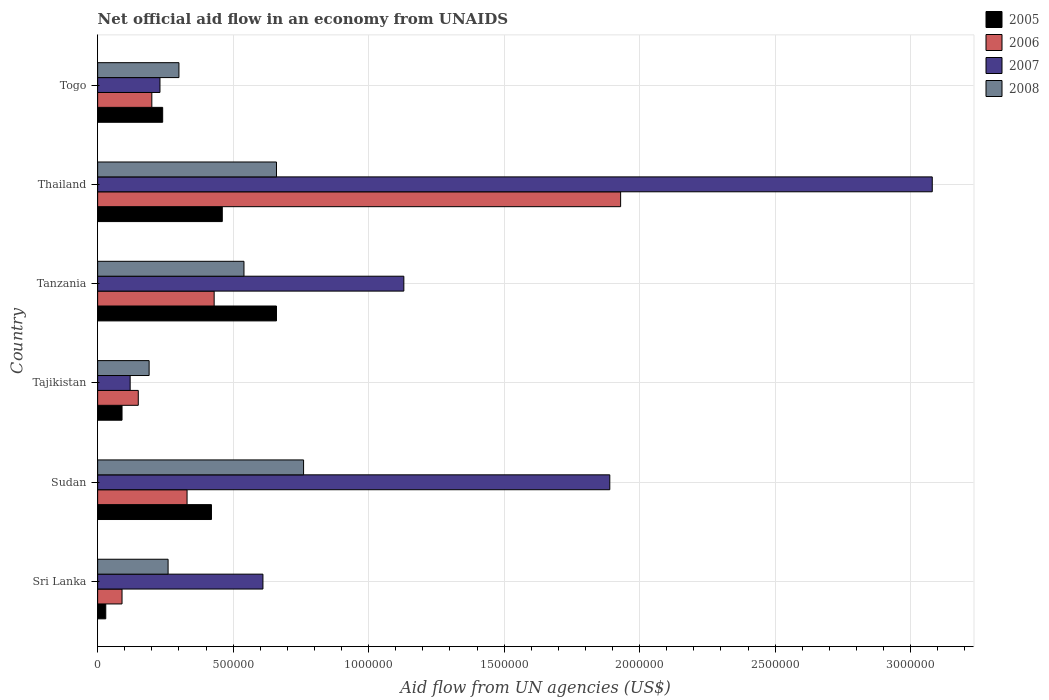Are the number of bars on each tick of the Y-axis equal?
Provide a succinct answer. Yes. How many bars are there on the 3rd tick from the top?
Your response must be concise. 4. What is the label of the 1st group of bars from the top?
Provide a succinct answer. Togo. What is the net official aid flow in 2008 in Tajikistan?
Keep it short and to the point. 1.90e+05. In which country was the net official aid flow in 2005 maximum?
Make the answer very short. Tanzania. In which country was the net official aid flow in 2005 minimum?
Provide a short and direct response. Sri Lanka. What is the total net official aid flow in 2008 in the graph?
Give a very brief answer. 2.71e+06. What is the difference between the net official aid flow in 2007 in Sudan and that in Tanzania?
Make the answer very short. 7.60e+05. What is the difference between the net official aid flow in 2005 in Tajikistan and the net official aid flow in 2008 in Thailand?
Keep it short and to the point. -5.70e+05. What is the average net official aid flow in 2007 per country?
Your answer should be very brief. 1.18e+06. What is the difference between the net official aid flow in 2006 and net official aid flow in 2007 in Thailand?
Provide a succinct answer. -1.15e+06. What is the ratio of the net official aid flow in 2008 in Sri Lanka to that in Togo?
Offer a very short reply. 0.87. What is the difference between the highest and the second highest net official aid flow in 2006?
Offer a very short reply. 1.50e+06. What is the difference between the highest and the lowest net official aid flow in 2008?
Provide a succinct answer. 5.70e+05. In how many countries, is the net official aid flow in 2006 greater than the average net official aid flow in 2006 taken over all countries?
Keep it short and to the point. 1. What does the 3rd bar from the bottom in Sri Lanka represents?
Provide a succinct answer. 2007. Does the graph contain grids?
Provide a succinct answer. Yes. How are the legend labels stacked?
Your response must be concise. Vertical. What is the title of the graph?
Provide a short and direct response. Net official aid flow in an economy from UNAIDS. What is the label or title of the X-axis?
Keep it short and to the point. Aid flow from UN agencies (US$). What is the label or title of the Y-axis?
Provide a succinct answer. Country. What is the Aid flow from UN agencies (US$) in 2005 in Sri Lanka?
Ensure brevity in your answer.  3.00e+04. What is the Aid flow from UN agencies (US$) of 2006 in Sri Lanka?
Give a very brief answer. 9.00e+04. What is the Aid flow from UN agencies (US$) of 2005 in Sudan?
Your response must be concise. 4.20e+05. What is the Aid flow from UN agencies (US$) of 2007 in Sudan?
Your answer should be compact. 1.89e+06. What is the Aid flow from UN agencies (US$) of 2008 in Sudan?
Ensure brevity in your answer.  7.60e+05. What is the Aid flow from UN agencies (US$) in 2006 in Tanzania?
Your answer should be compact. 4.30e+05. What is the Aid flow from UN agencies (US$) of 2007 in Tanzania?
Your answer should be compact. 1.13e+06. What is the Aid flow from UN agencies (US$) in 2008 in Tanzania?
Your answer should be very brief. 5.40e+05. What is the Aid flow from UN agencies (US$) of 2005 in Thailand?
Your answer should be compact. 4.60e+05. What is the Aid flow from UN agencies (US$) in 2006 in Thailand?
Provide a succinct answer. 1.93e+06. What is the Aid flow from UN agencies (US$) in 2007 in Thailand?
Give a very brief answer. 3.08e+06. What is the Aid flow from UN agencies (US$) of 2008 in Thailand?
Your response must be concise. 6.60e+05. What is the Aid flow from UN agencies (US$) of 2005 in Togo?
Your answer should be compact. 2.40e+05. What is the Aid flow from UN agencies (US$) in 2008 in Togo?
Your response must be concise. 3.00e+05. Across all countries, what is the maximum Aid flow from UN agencies (US$) in 2005?
Provide a succinct answer. 6.60e+05. Across all countries, what is the maximum Aid flow from UN agencies (US$) in 2006?
Offer a very short reply. 1.93e+06. Across all countries, what is the maximum Aid flow from UN agencies (US$) of 2007?
Your response must be concise. 3.08e+06. Across all countries, what is the maximum Aid flow from UN agencies (US$) of 2008?
Offer a very short reply. 7.60e+05. What is the total Aid flow from UN agencies (US$) of 2005 in the graph?
Provide a succinct answer. 1.90e+06. What is the total Aid flow from UN agencies (US$) of 2006 in the graph?
Make the answer very short. 3.13e+06. What is the total Aid flow from UN agencies (US$) in 2007 in the graph?
Your answer should be compact. 7.06e+06. What is the total Aid flow from UN agencies (US$) of 2008 in the graph?
Provide a succinct answer. 2.71e+06. What is the difference between the Aid flow from UN agencies (US$) in 2005 in Sri Lanka and that in Sudan?
Ensure brevity in your answer.  -3.90e+05. What is the difference between the Aid flow from UN agencies (US$) of 2007 in Sri Lanka and that in Sudan?
Make the answer very short. -1.28e+06. What is the difference between the Aid flow from UN agencies (US$) in 2008 in Sri Lanka and that in Sudan?
Provide a short and direct response. -5.00e+05. What is the difference between the Aid flow from UN agencies (US$) in 2007 in Sri Lanka and that in Tajikistan?
Your answer should be very brief. 4.90e+05. What is the difference between the Aid flow from UN agencies (US$) of 2008 in Sri Lanka and that in Tajikistan?
Ensure brevity in your answer.  7.00e+04. What is the difference between the Aid flow from UN agencies (US$) of 2005 in Sri Lanka and that in Tanzania?
Make the answer very short. -6.30e+05. What is the difference between the Aid flow from UN agencies (US$) in 2007 in Sri Lanka and that in Tanzania?
Keep it short and to the point. -5.20e+05. What is the difference between the Aid flow from UN agencies (US$) of 2008 in Sri Lanka and that in Tanzania?
Give a very brief answer. -2.80e+05. What is the difference between the Aid flow from UN agencies (US$) in 2005 in Sri Lanka and that in Thailand?
Keep it short and to the point. -4.30e+05. What is the difference between the Aid flow from UN agencies (US$) in 2006 in Sri Lanka and that in Thailand?
Ensure brevity in your answer.  -1.84e+06. What is the difference between the Aid flow from UN agencies (US$) of 2007 in Sri Lanka and that in Thailand?
Keep it short and to the point. -2.47e+06. What is the difference between the Aid flow from UN agencies (US$) of 2008 in Sri Lanka and that in Thailand?
Your answer should be very brief. -4.00e+05. What is the difference between the Aid flow from UN agencies (US$) of 2005 in Sri Lanka and that in Togo?
Offer a very short reply. -2.10e+05. What is the difference between the Aid flow from UN agencies (US$) of 2006 in Sri Lanka and that in Togo?
Ensure brevity in your answer.  -1.10e+05. What is the difference between the Aid flow from UN agencies (US$) of 2008 in Sri Lanka and that in Togo?
Your answer should be very brief. -4.00e+04. What is the difference between the Aid flow from UN agencies (US$) of 2005 in Sudan and that in Tajikistan?
Offer a terse response. 3.30e+05. What is the difference between the Aid flow from UN agencies (US$) in 2007 in Sudan and that in Tajikistan?
Your response must be concise. 1.77e+06. What is the difference between the Aid flow from UN agencies (US$) of 2008 in Sudan and that in Tajikistan?
Provide a short and direct response. 5.70e+05. What is the difference between the Aid flow from UN agencies (US$) of 2007 in Sudan and that in Tanzania?
Ensure brevity in your answer.  7.60e+05. What is the difference between the Aid flow from UN agencies (US$) in 2008 in Sudan and that in Tanzania?
Your response must be concise. 2.20e+05. What is the difference between the Aid flow from UN agencies (US$) of 2006 in Sudan and that in Thailand?
Your answer should be very brief. -1.60e+06. What is the difference between the Aid flow from UN agencies (US$) of 2007 in Sudan and that in Thailand?
Make the answer very short. -1.19e+06. What is the difference between the Aid flow from UN agencies (US$) of 2008 in Sudan and that in Thailand?
Your answer should be compact. 1.00e+05. What is the difference between the Aid flow from UN agencies (US$) in 2005 in Sudan and that in Togo?
Your response must be concise. 1.80e+05. What is the difference between the Aid flow from UN agencies (US$) of 2006 in Sudan and that in Togo?
Offer a terse response. 1.30e+05. What is the difference between the Aid flow from UN agencies (US$) in 2007 in Sudan and that in Togo?
Provide a short and direct response. 1.66e+06. What is the difference between the Aid flow from UN agencies (US$) in 2008 in Sudan and that in Togo?
Provide a short and direct response. 4.60e+05. What is the difference between the Aid flow from UN agencies (US$) in 2005 in Tajikistan and that in Tanzania?
Offer a very short reply. -5.70e+05. What is the difference between the Aid flow from UN agencies (US$) in 2006 in Tajikistan and that in Tanzania?
Provide a short and direct response. -2.80e+05. What is the difference between the Aid flow from UN agencies (US$) of 2007 in Tajikistan and that in Tanzania?
Your answer should be very brief. -1.01e+06. What is the difference between the Aid flow from UN agencies (US$) of 2008 in Tajikistan and that in Tanzania?
Your answer should be very brief. -3.50e+05. What is the difference between the Aid flow from UN agencies (US$) in 2005 in Tajikistan and that in Thailand?
Provide a succinct answer. -3.70e+05. What is the difference between the Aid flow from UN agencies (US$) of 2006 in Tajikistan and that in Thailand?
Offer a very short reply. -1.78e+06. What is the difference between the Aid flow from UN agencies (US$) of 2007 in Tajikistan and that in Thailand?
Give a very brief answer. -2.96e+06. What is the difference between the Aid flow from UN agencies (US$) in 2008 in Tajikistan and that in Thailand?
Make the answer very short. -4.70e+05. What is the difference between the Aid flow from UN agencies (US$) of 2006 in Tajikistan and that in Togo?
Your answer should be compact. -5.00e+04. What is the difference between the Aid flow from UN agencies (US$) in 2007 in Tajikistan and that in Togo?
Offer a terse response. -1.10e+05. What is the difference between the Aid flow from UN agencies (US$) of 2006 in Tanzania and that in Thailand?
Make the answer very short. -1.50e+06. What is the difference between the Aid flow from UN agencies (US$) of 2007 in Tanzania and that in Thailand?
Offer a very short reply. -1.95e+06. What is the difference between the Aid flow from UN agencies (US$) in 2008 in Tanzania and that in Thailand?
Give a very brief answer. -1.20e+05. What is the difference between the Aid flow from UN agencies (US$) in 2007 in Tanzania and that in Togo?
Your response must be concise. 9.00e+05. What is the difference between the Aid flow from UN agencies (US$) in 2006 in Thailand and that in Togo?
Your answer should be compact. 1.73e+06. What is the difference between the Aid flow from UN agencies (US$) of 2007 in Thailand and that in Togo?
Your answer should be very brief. 2.85e+06. What is the difference between the Aid flow from UN agencies (US$) in 2005 in Sri Lanka and the Aid flow from UN agencies (US$) in 2006 in Sudan?
Give a very brief answer. -3.00e+05. What is the difference between the Aid flow from UN agencies (US$) of 2005 in Sri Lanka and the Aid flow from UN agencies (US$) of 2007 in Sudan?
Keep it short and to the point. -1.86e+06. What is the difference between the Aid flow from UN agencies (US$) of 2005 in Sri Lanka and the Aid flow from UN agencies (US$) of 2008 in Sudan?
Offer a very short reply. -7.30e+05. What is the difference between the Aid flow from UN agencies (US$) in 2006 in Sri Lanka and the Aid flow from UN agencies (US$) in 2007 in Sudan?
Your response must be concise. -1.80e+06. What is the difference between the Aid flow from UN agencies (US$) of 2006 in Sri Lanka and the Aid flow from UN agencies (US$) of 2008 in Sudan?
Offer a very short reply. -6.70e+05. What is the difference between the Aid flow from UN agencies (US$) in 2006 in Sri Lanka and the Aid flow from UN agencies (US$) in 2008 in Tajikistan?
Your answer should be very brief. -1.00e+05. What is the difference between the Aid flow from UN agencies (US$) of 2007 in Sri Lanka and the Aid flow from UN agencies (US$) of 2008 in Tajikistan?
Ensure brevity in your answer.  4.20e+05. What is the difference between the Aid flow from UN agencies (US$) of 2005 in Sri Lanka and the Aid flow from UN agencies (US$) of 2006 in Tanzania?
Your answer should be compact. -4.00e+05. What is the difference between the Aid flow from UN agencies (US$) of 2005 in Sri Lanka and the Aid flow from UN agencies (US$) of 2007 in Tanzania?
Your answer should be compact. -1.10e+06. What is the difference between the Aid flow from UN agencies (US$) in 2005 in Sri Lanka and the Aid flow from UN agencies (US$) in 2008 in Tanzania?
Your response must be concise. -5.10e+05. What is the difference between the Aid flow from UN agencies (US$) in 2006 in Sri Lanka and the Aid flow from UN agencies (US$) in 2007 in Tanzania?
Ensure brevity in your answer.  -1.04e+06. What is the difference between the Aid flow from UN agencies (US$) in 2006 in Sri Lanka and the Aid flow from UN agencies (US$) in 2008 in Tanzania?
Provide a short and direct response. -4.50e+05. What is the difference between the Aid flow from UN agencies (US$) of 2007 in Sri Lanka and the Aid flow from UN agencies (US$) of 2008 in Tanzania?
Give a very brief answer. 7.00e+04. What is the difference between the Aid flow from UN agencies (US$) in 2005 in Sri Lanka and the Aid flow from UN agencies (US$) in 2006 in Thailand?
Make the answer very short. -1.90e+06. What is the difference between the Aid flow from UN agencies (US$) in 2005 in Sri Lanka and the Aid flow from UN agencies (US$) in 2007 in Thailand?
Provide a succinct answer. -3.05e+06. What is the difference between the Aid flow from UN agencies (US$) in 2005 in Sri Lanka and the Aid flow from UN agencies (US$) in 2008 in Thailand?
Keep it short and to the point. -6.30e+05. What is the difference between the Aid flow from UN agencies (US$) in 2006 in Sri Lanka and the Aid flow from UN agencies (US$) in 2007 in Thailand?
Provide a short and direct response. -2.99e+06. What is the difference between the Aid flow from UN agencies (US$) of 2006 in Sri Lanka and the Aid flow from UN agencies (US$) of 2008 in Thailand?
Give a very brief answer. -5.70e+05. What is the difference between the Aid flow from UN agencies (US$) in 2005 in Sri Lanka and the Aid flow from UN agencies (US$) in 2007 in Togo?
Offer a very short reply. -2.00e+05. What is the difference between the Aid flow from UN agencies (US$) in 2007 in Sri Lanka and the Aid flow from UN agencies (US$) in 2008 in Togo?
Provide a succinct answer. 3.10e+05. What is the difference between the Aid flow from UN agencies (US$) of 2005 in Sudan and the Aid flow from UN agencies (US$) of 2006 in Tajikistan?
Offer a terse response. 2.70e+05. What is the difference between the Aid flow from UN agencies (US$) in 2005 in Sudan and the Aid flow from UN agencies (US$) in 2008 in Tajikistan?
Offer a terse response. 2.30e+05. What is the difference between the Aid flow from UN agencies (US$) in 2006 in Sudan and the Aid flow from UN agencies (US$) in 2007 in Tajikistan?
Offer a very short reply. 2.10e+05. What is the difference between the Aid flow from UN agencies (US$) of 2007 in Sudan and the Aid flow from UN agencies (US$) of 2008 in Tajikistan?
Offer a very short reply. 1.70e+06. What is the difference between the Aid flow from UN agencies (US$) of 2005 in Sudan and the Aid flow from UN agencies (US$) of 2006 in Tanzania?
Ensure brevity in your answer.  -10000. What is the difference between the Aid flow from UN agencies (US$) of 2005 in Sudan and the Aid flow from UN agencies (US$) of 2007 in Tanzania?
Keep it short and to the point. -7.10e+05. What is the difference between the Aid flow from UN agencies (US$) in 2006 in Sudan and the Aid flow from UN agencies (US$) in 2007 in Tanzania?
Keep it short and to the point. -8.00e+05. What is the difference between the Aid flow from UN agencies (US$) in 2007 in Sudan and the Aid flow from UN agencies (US$) in 2008 in Tanzania?
Provide a short and direct response. 1.35e+06. What is the difference between the Aid flow from UN agencies (US$) in 2005 in Sudan and the Aid flow from UN agencies (US$) in 2006 in Thailand?
Provide a short and direct response. -1.51e+06. What is the difference between the Aid flow from UN agencies (US$) of 2005 in Sudan and the Aid flow from UN agencies (US$) of 2007 in Thailand?
Offer a terse response. -2.66e+06. What is the difference between the Aid flow from UN agencies (US$) of 2006 in Sudan and the Aid flow from UN agencies (US$) of 2007 in Thailand?
Your answer should be very brief. -2.75e+06. What is the difference between the Aid flow from UN agencies (US$) in 2006 in Sudan and the Aid flow from UN agencies (US$) in 2008 in Thailand?
Ensure brevity in your answer.  -3.30e+05. What is the difference between the Aid flow from UN agencies (US$) of 2007 in Sudan and the Aid flow from UN agencies (US$) of 2008 in Thailand?
Make the answer very short. 1.23e+06. What is the difference between the Aid flow from UN agencies (US$) of 2005 in Sudan and the Aid flow from UN agencies (US$) of 2008 in Togo?
Your response must be concise. 1.20e+05. What is the difference between the Aid flow from UN agencies (US$) in 2006 in Sudan and the Aid flow from UN agencies (US$) in 2007 in Togo?
Provide a succinct answer. 1.00e+05. What is the difference between the Aid flow from UN agencies (US$) in 2007 in Sudan and the Aid flow from UN agencies (US$) in 2008 in Togo?
Offer a terse response. 1.59e+06. What is the difference between the Aid flow from UN agencies (US$) in 2005 in Tajikistan and the Aid flow from UN agencies (US$) in 2006 in Tanzania?
Offer a very short reply. -3.40e+05. What is the difference between the Aid flow from UN agencies (US$) in 2005 in Tajikistan and the Aid flow from UN agencies (US$) in 2007 in Tanzania?
Your answer should be compact. -1.04e+06. What is the difference between the Aid flow from UN agencies (US$) in 2005 in Tajikistan and the Aid flow from UN agencies (US$) in 2008 in Tanzania?
Your answer should be very brief. -4.50e+05. What is the difference between the Aid flow from UN agencies (US$) in 2006 in Tajikistan and the Aid flow from UN agencies (US$) in 2007 in Tanzania?
Ensure brevity in your answer.  -9.80e+05. What is the difference between the Aid flow from UN agencies (US$) of 2006 in Tajikistan and the Aid flow from UN agencies (US$) of 2008 in Tanzania?
Your response must be concise. -3.90e+05. What is the difference between the Aid flow from UN agencies (US$) in 2007 in Tajikistan and the Aid flow from UN agencies (US$) in 2008 in Tanzania?
Provide a short and direct response. -4.20e+05. What is the difference between the Aid flow from UN agencies (US$) of 2005 in Tajikistan and the Aid flow from UN agencies (US$) of 2006 in Thailand?
Your answer should be very brief. -1.84e+06. What is the difference between the Aid flow from UN agencies (US$) of 2005 in Tajikistan and the Aid flow from UN agencies (US$) of 2007 in Thailand?
Give a very brief answer. -2.99e+06. What is the difference between the Aid flow from UN agencies (US$) in 2005 in Tajikistan and the Aid flow from UN agencies (US$) in 2008 in Thailand?
Your response must be concise. -5.70e+05. What is the difference between the Aid flow from UN agencies (US$) in 2006 in Tajikistan and the Aid flow from UN agencies (US$) in 2007 in Thailand?
Your answer should be compact. -2.93e+06. What is the difference between the Aid flow from UN agencies (US$) of 2006 in Tajikistan and the Aid flow from UN agencies (US$) of 2008 in Thailand?
Your answer should be very brief. -5.10e+05. What is the difference between the Aid flow from UN agencies (US$) in 2007 in Tajikistan and the Aid flow from UN agencies (US$) in 2008 in Thailand?
Offer a very short reply. -5.40e+05. What is the difference between the Aid flow from UN agencies (US$) of 2005 in Tajikistan and the Aid flow from UN agencies (US$) of 2006 in Togo?
Offer a very short reply. -1.10e+05. What is the difference between the Aid flow from UN agencies (US$) of 2005 in Tajikistan and the Aid flow from UN agencies (US$) of 2007 in Togo?
Keep it short and to the point. -1.40e+05. What is the difference between the Aid flow from UN agencies (US$) of 2005 in Tajikistan and the Aid flow from UN agencies (US$) of 2008 in Togo?
Provide a succinct answer. -2.10e+05. What is the difference between the Aid flow from UN agencies (US$) of 2006 in Tajikistan and the Aid flow from UN agencies (US$) of 2007 in Togo?
Ensure brevity in your answer.  -8.00e+04. What is the difference between the Aid flow from UN agencies (US$) of 2006 in Tajikistan and the Aid flow from UN agencies (US$) of 2008 in Togo?
Your answer should be compact. -1.50e+05. What is the difference between the Aid flow from UN agencies (US$) of 2005 in Tanzania and the Aid flow from UN agencies (US$) of 2006 in Thailand?
Make the answer very short. -1.27e+06. What is the difference between the Aid flow from UN agencies (US$) of 2005 in Tanzania and the Aid flow from UN agencies (US$) of 2007 in Thailand?
Offer a terse response. -2.42e+06. What is the difference between the Aid flow from UN agencies (US$) in 2005 in Tanzania and the Aid flow from UN agencies (US$) in 2008 in Thailand?
Make the answer very short. 0. What is the difference between the Aid flow from UN agencies (US$) in 2006 in Tanzania and the Aid flow from UN agencies (US$) in 2007 in Thailand?
Your response must be concise. -2.65e+06. What is the difference between the Aid flow from UN agencies (US$) in 2006 in Tanzania and the Aid flow from UN agencies (US$) in 2008 in Togo?
Your answer should be compact. 1.30e+05. What is the difference between the Aid flow from UN agencies (US$) in 2007 in Tanzania and the Aid flow from UN agencies (US$) in 2008 in Togo?
Make the answer very short. 8.30e+05. What is the difference between the Aid flow from UN agencies (US$) of 2006 in Thailand and the Aid flow from UN agencies (US$) of 2007 in Togo?
Provide a short and direct response. 1.70e+06. What is the difference between the Aid flow from UN agencies (US$) of 2006 in Thailand and the Aid flow from UN agencies (US$) of 2008 in Togo?
Offer a terse response. 1.63e+06. What is the difference between the Aid flow from UN agencies (US$) of 2007 in Thailand and the Aid flow from UN agencies (US$) of 2008 in Togo?
Make the answer very short. 2.78e+06. What is the average Aid flow from UN agencies (US$) of 2005 per country?
Provide a succinct answer. 3.17e+05. What is the average Aid flow from UN agencies (US$) of 2006 per country?
Keep it short and to the point. 5.22e+05. What is the average Aid flow from UN agencies (US$) of 2007 per country?
Offer a terse response. 1.18e+06. What is the average Aid flow from UN agencies (US$) in 2008 per country?
Your answer should be compact. 4.52e+05. What is the difference between the Aid flow from UN agencies (US$) in 2005 and Aid flow from UN agencies (US$) in 2006 in Sri Lanka?
Give a very brief answer. -6.00e+04. What is the difference between the Aid flow from UN agencies (US$) of 2005 and Aid flow from UN agencies (US$) of 2007 in Sri Lanka?
Make the answer very short. -5.80e+05. What is the difference between the Aid flow from UN agencies (US$) of 2006 and Aid flow from UN agencies (US$) of 2007 in Sri Lanka?
Provide a short and direct response. -5.20e+05. What is the difference between the Aid flow from UN agencies (US$) in 2006 and Aid flow from UN agencies (US$) in 2008 in Sri Lanka?
Keep it short and to the point. -1.70e+05. What is the difference between the Aid flow from UN agencies (US$) in 2007 and Aid flow from UN agencies (US$) in 2008 in Sri Lanka?
Provide a short and direct response. 3.50e+05. What is the difference between the Aid flow from UN agencies (US$) of 2005 and Aid flow from UN agencies (US$) of 2007 in Sudan?
Ensure brevity in your answer.  -1.47e+06. What is the difference between the Aid flow from UN agencies (US$) of 2005 and Aid flow from UN agencies (US$) of 2008 in Sudan?
Give a very brief answer. -3.40e+05. What is the difference between the Aid flow from UN agencies (US$) of 2006 and Aid flow from UN agencies (US$) of 2007 in Sudan?
Keep it short and to the point. -1.56e+06. What is the difference between the Aid flow from UN agencies (US$) in 2006 and Aid flow from UN agencies (US$) in 2008 in Sudan?
Ensure brevity in your answer.  -4.30e+05. What is the difference between the Aid flow from UN agencies (US$) of 2007 and Aid flow from UN agencies (US$) of 2008 in Sudan?
Your answer should be compact. 1.13e+06. What is the difference between the Aid flow from UN agencies (US$) in 2006 and Aid flow from UN agencies (US$) in 2007 in Tajikistan?
Ensure brevity in your answer.  3.00e+04. What is the difference between the Aid flow from UN agencies (US$) of 2006 and Aid flow from UN agencies (US$) of 2008 in Tajikistan?
Offer a terse response. -4.00e+04. What is the difference between the Aid flow from UN agencies (US$) of 2005 and Aid flow from UN agencies (US$) of 2006 in Tanzania?
Your answer should be compact. 2.30e+05. What is the difference between the Aid flow from UN agencies (US$) of 2005 and Aid flow from UN agencies (US$) of 2007 in Tanzania?
Your response must be concise. -4.70e+05. What is the difference between the Aid flow from UN agencies (US$) in 2006 and Aid flow from UN agencies (US$) in 2007 in Tanzania?
Offer a terse response. -7.00e+05. What is the difference between the Aid flow from UN agencies (US$) of 2006 and Aid flow from UN agencies (US$) of 2008 in Tanzania?
Keep it short and to the point. -1.10e+05. What is the difference between the Aid flow from UN agencies (US$) in 2007 and Aid flow from UN agencies (US$) in 2008 in Tanzania?
Ensure brevity in your answer.  5.90e+05. What is the difference between the Aid flow from UN agencies (US$) of 2005 and Aid flow from UN agencies (US$) of 2006 in Thailand?
Ensure brevity in your answer.  -1.47e+06. What is the difference between the Aid flow from UN agencies (US$) in 2005 and Aid flow from UN agencies (US$) in 2007 in Thailand?
Your answer should be compact. -2.62e+06. What is the difference between the Aid flow from UN agencies (US$) of 2006 and Aid flow from UN agencies (US$) of 2007 in Thailand?
Provide a succinct answer. -1.15e+06. What is the difference between the Aid flow from UN agencies (US$) in 2006 and Aid flow from UN agencies (US$) in 2008 in Thailand?
Your answer should be compact. 1.27e+06. What is the difference between the Aid flow from UN agencies (US$) in 2007 and Aid flow from UN agencies (US$) in 2008 in Thailand?
Your response must be concise. 2.42e+06. What is the difference between the Aid flow from UN agencies (US$) in 2005 and Aid flow from UN agencies (US$) in 2008 in Togo?
Offer a terse response. -6.00e+04. What is the difference between the Aid flow from UN agencies (US$) in 2006 and Aid flow from UN agencies (US$) in 2007 in Togo?
Make the answer very short. -3.00e+04. What is the difference between the Aid flow from UN agencies (US$) of 2007 and Aid flow from UN agencies (US$) of 2008 in Togo?
Your answer should be compact. -7.00e+04. What is the ratio of the Aid flow from UN agencies (US$) in 2005 in Sri Lanka to that in Sudan?
Provide a succinct answer. 0.07. What is the ratio of the Aid flow from UN agencies (US$) in 2006 in Sri Lanka to that in Sudan?
Give a very brief answer. 0.27. What is the ratio of the Aid flow from UN agencies (US$) of 2007 in Sri Lanka to that in Sudan?
Offer a very short reply. 0.32. What is the ratio of the Aid flow from UN agencies (US$) in 2008 in Sri Lanka to that in Sudan?
Make the answer very short. 0.34. What is the ratio of the Aid flow from UN agencies (US$) in 2005 in Sri Lanka to that in Tajikistan?
Offer a terse response. 0.33. What is the ratio of the Aid flow from UN agencies (US$) in 2006 in Sri Lanka to that in Tajikistan?
Ensure brevity in your answer.  0.6. What is the ratio of the Aid flow from UN agencies (US$) of 2007 in Sri Lanka to that in Tajikistan?
Provide a succinct answer. 5.08. What is the ratio of the Aid flow from UN agencies (US$) of 2008 in Sri Lanka to that in Tajikistan?
Your answer should be compact. 1.37. What is the ratio of the Aid flow from UN agencies (US$) of 2005 in Sri Lanka to that in Tanzania?
Your answer should be compact. 0.05. What is the ratio of the Aid flow from UN agencies (US$) in 2006 in Sri Lanka to that in Tanzania?
Provide a succinct answer. 0.21. What is the ratio of the Aid flow from UN agencies (US$) in 2007 in Sri Lanka to that in Tanzania?
Give a very brief answer. 0.54. What is the ratio of the Aid flow from UN agencies (US$) in 2008 in Sri Lanka to that in Tanzania?
Ensure brevity in your answer.  0.48. What is the ratio of the Aid flow from UN agencies (US$) in 2005 in Sri Lanka to that in Thailand?
Provide a short and direct response. 0.07. What is the ratio of the Aid flow from UN agencies (US$) in 2006 in Sri Lanka to that in Thailand?
Make the answer very short. 0.05. What is the ratio of the Aid flow from UN agencies (US$) in 2007 in Sri Lanka to that in Thailand?
Ensure brevity in your answer.  0.2. What is the ratio of the Aid flow from UN agencies (US$) in 2008 in Sri Lanka to that in Thailand?
Give a very brief answer. 0.39. What is the ratio of the Aid flow from UN agencies (US$) in 2005 in Sri Lanka to that in Togo?
Give a very brief answer. 0.12. What is the ratio of the Aid flow from UN agencies (US$) in 2006 in Sri Lanka to that in Togo?
Keep it short and to the point. 0.45. What is the ratio of the Aid flow from UN agencies (US$) in 2007 in Sri Lanka to that in Togo?
Offer a terse response. 2.65. What is the ratio of the Aid flow from UN agencies (US$) of 2008 in Sri Lanka to that in Togo?
Provide a succinct answer. 0.87. What is the ratio of the Aid flow from UN agencies (US$) in 2005 in Sudan to that in Tajikistan?
Offer a very short reply. 4.67. What is the ratio of the Aid flow from UN agencies (US$) in 2006 in Sudan to that in Tajikistan?
Offer a terse response. 2.2. What is the ratio of the Aid flow from UN agencies (US$) in 2007 in Sudan to that in Tajikistan?
Provide a succinct answer. 15.75. What is the ratio of the Aid flow from UN agencies (US$) of 2008 in Sudan to that in Tajikistan?
Your answer should be very brief. 4. What is the ratio of the Aid flow from UN agencies (US$) of 2005 in Sudan to that in Tanzania?
Make the answer very short. 0.64. What is the ratio of the Aid flow from UN agencies (US$) in 2006 in Sudan to that in Tanzania?
Your response must be concise. 0.77. What is the ratio of the Aid flow from UN agencies (US$) in 2007 in Sudan to that in Tanzania?
Offer a terse response. 1.67. What is the ratio of the Aid flow from UN agencies (US$) in 2008 in Sudan to that in Tanzania?
Your response must be concise. 1.41. What is the ratio of the Aid flow from UN agencies (US$) in 2005 in Sudan to that in Thailand?
Your answer should be very brief. 0.91. What is the ratio of the Aid flow from UN agencies (US$) of 2006 in Sudan to that in Thailand?
Ensure brevity in your answer.  0.17. What is the ratio of the Aid flow from UN agencies (US$) in 2007 in Sudan to that in Thailand?
Keep it short and to the point. 0.61. What is the ratio of the Aid flow from UN agencies (US$) of 2008 in Sudan to that in Thailand?
Ensure brevity in your answer.  1.15. What is the ratio of the Aid flow from UN agencies (US$) in 2005 in Sudan to that in Togo?
Provide a succinct answer. 1.75. What is the ratio of the Aid flow from UN agencies (US$) of 2006 in Sudan to that in Togo?
Keep it short and to the point. 1.65. What is the ratio of the Aid flow from UN agencies (US$) of 2007 in Sudan to that in Togo?
Your answer should be compact. 8.22. What is the ratio of the Aid flow from UN agencies (US$) of 2008 in Sudan to that in Togo?
Give a very brief answer. 2.53. What is the ratio of the Aid flow from UN agencies (US$) in 2005 in Tajikistan to that in Tanzania?
Offer a very short reply. 0.14. What is the ratio of the Aid flow from UN agencies (US$) of 2006 in Tajikistan to that in Tanzania?
Your answer should be compact. 0.35. What is the ratio of the Aid flow from UN agencies (US$) in 2007 in Tajikistan to that in Tanzania?
Your response must be concise. 0.11. What is the ratio of the Aid flow from UN agencies (US$) in 2008 in Tajikistan to that in Tanzania?
Offer a very short reply. 0.35. What is the ratio of the Aid flow from UN agencies (US$) of 2005 in Tajikistan to that in Thailand?
Keep it short and to the point. 0.2. What is the ratio of the Aid flow from UN agencies (US$) in 2006 in Tajikistan to that in Thailand?
Make the answer very short. 0.08. What is the ratio of the Aid flow from UN agencies (US$) of 2007 in Tajikistan to that in Thailand?
Offer a terse response. 0.04. What is the ratio of the Aid flow from UN agencies (US$) in 2008 in Tajikistan to that in Thailand?
Your answer should be compact. 0.29. What is the ratio of the Aid flow from UN agencies (US$) in 2005 in Tajikistan to that in Togo?
Offer a very short reply. 0.38. What is the ratio of the Aid flow from UN agencies (US$) in 2006 in Tajikistan to that in Togo?
Ensure brevity in your answer.  0.75. What is the ratio of the Aid flow from UN agencies (US$) of 2007 in Tajikistan to that in Togo?
Make the answer very short. 0.52. What is the ratio of the Aid flow from UN agencies (US$) in 2008 in Tajikistan to that in Togo?
Offer a very short reply. 0.63. What is the ratio of the Aid flow from UN agencies (US$) in 2005 in Tanzania to that in Thailand?
Make the answer very short. 1.43. What is the ratio of the Aid flow from UN agencies (US$) of 2006 in Tanzania to that in Thailand?
Offer a very short reply. 0.22. What is the ratio of the Aid flow from UN agencies (US$) of 2007 in Tanzania to that in Thailand?
Keep it short and to the point. 0.37. What is the ratio of the Aid flow from UN agencies (US$) of 2008 in Tanzania to that in Thailand?
Keep it short and to the point. 0.82. What is the ratio of the Aid flow from UN agencies (US$) of 2005 in Tanzania to that in Togo?
Make the answer very short. 2.75. What is the ratio of the Aid flow from UN agencies (US$) of 2006 in Tanzania to that in Togo?
Provide a short and direct response. 2.15. What is the ratio of the Aid flow from UN agencies (US$) in 2007 in Tanzania to that in Togo?
Keep it short and to the point. 4.91. What is the ratio of the Aid flow from UN agencies (US$) of 2005 in Thailand to that in Togo?
Offer a terse response. 1.92. What is the ratio of the Aid flow from UN agencies (US$) in 2006 in Thailand to that in Togo?
Give a very brief answer. 9.65. What is the ratio of the Aid flow from UN agencies (US$) in 2007 in Thailand to that in Togo?
Keep it short and to the point. 13.39. What is the difference between the highest and the second highest Aid flow from UN agencies (US$) of 2005?
Your answer should be compact. 2.00e+05. What is the difference between the highest and the second highest Aid flow from UN agencies (US$) of 2006?
Your answer should be very brief. 1.50e+06. What is the difference between the highest and the second highest Aid flow from UN agencies (US$) in 2007?
Ensure brevity in your answer.  1.19e+06. What is the difference between the highest and the lowest Aid flow from UN agencies (US$) of 2005?
Provide a short and direct response. 6.30e+05. What is the difference between the highest and the lowest Aid flow from UN agencies (US$) in 2006?
Keep it short and to the point. 1.84e+06. What is the difference between the highest and the lowest Aid flow from UN agencies (US$) in 2007?
Offer a terse response. 2.96e+06. What is the difference between the highest and the lowest Aid flow from UN agencies (US$) of 2008?
Your answer should be compact. 5.70e+05. 